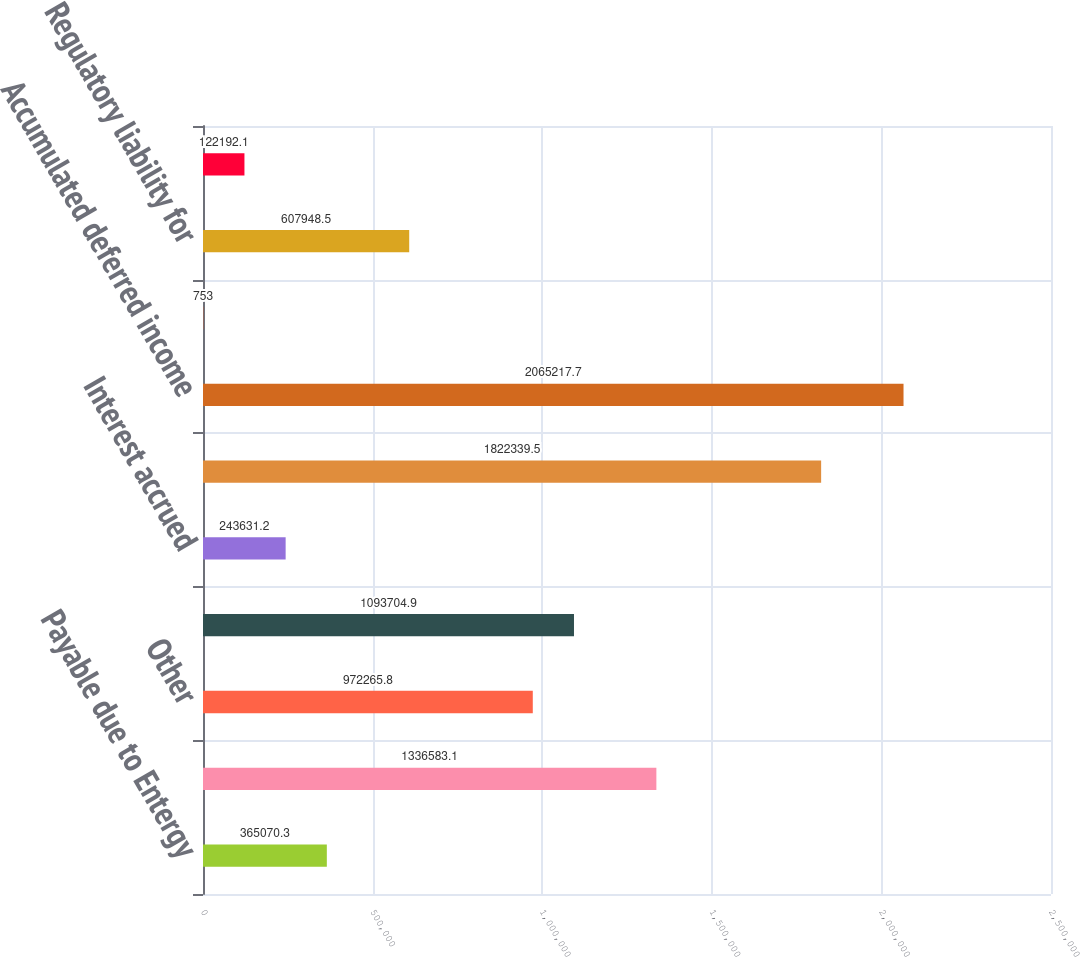<chart> <loc_0><loc_0><loc_500><loc_500><bar_chart><fcel>Payable due to Entergy<fcel>Associated companies<fcel>Other<fcel>Customer deposits<fcel>Interest accrued<fcel>TOTAL CURRENT LIABILITIES<fcel>Accumulated deferred income<fcel>Accumulated deferred<fcel>Regulatory liability for<fcel>Asset retirement cost<nl><fcel>365070<fcel>1.33658e+06<fcel>972266<fcel>1.0937e+06<fcel>243631<fcel>1.82234e+06<fcel>2.06522e+06<fcel>753<fcel>607948<fcel>122192<nl></chart> 